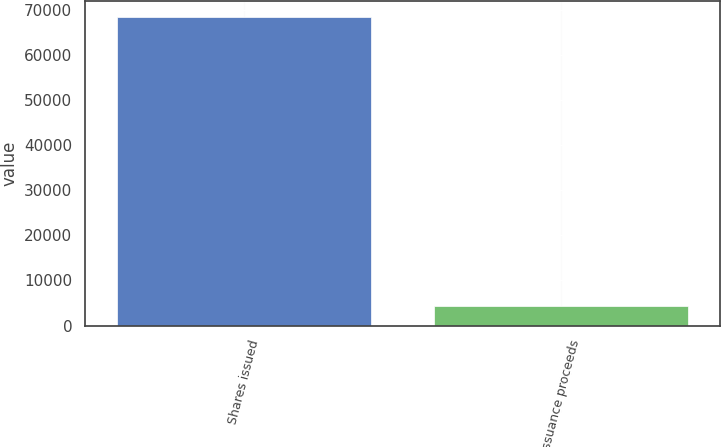Convert chart. <chart><loc_0><loc_0><loc_500><loc_500><bar_chart><fcel>Shares issued<fcel>Issuance proceeds<nl><fcel>68462<fcel>4404<nl></chart> 